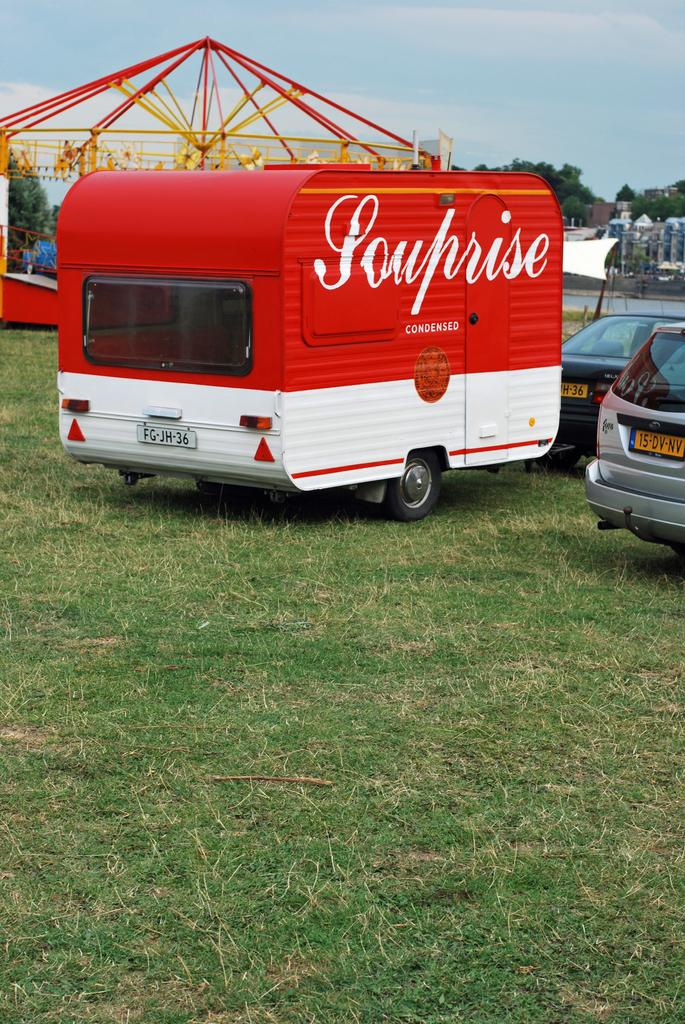What is located in the center of the image? There are vehicles in the center of the image. What can be seen in the background of the image? Sky, clouds, trees, buildings, water, and a child carousel are visible in the background of the image. What type of wood is used to build the nerve center of the cherry factory in the image? There is no mention of a cherry factory or any wood or nerve center in the image. 